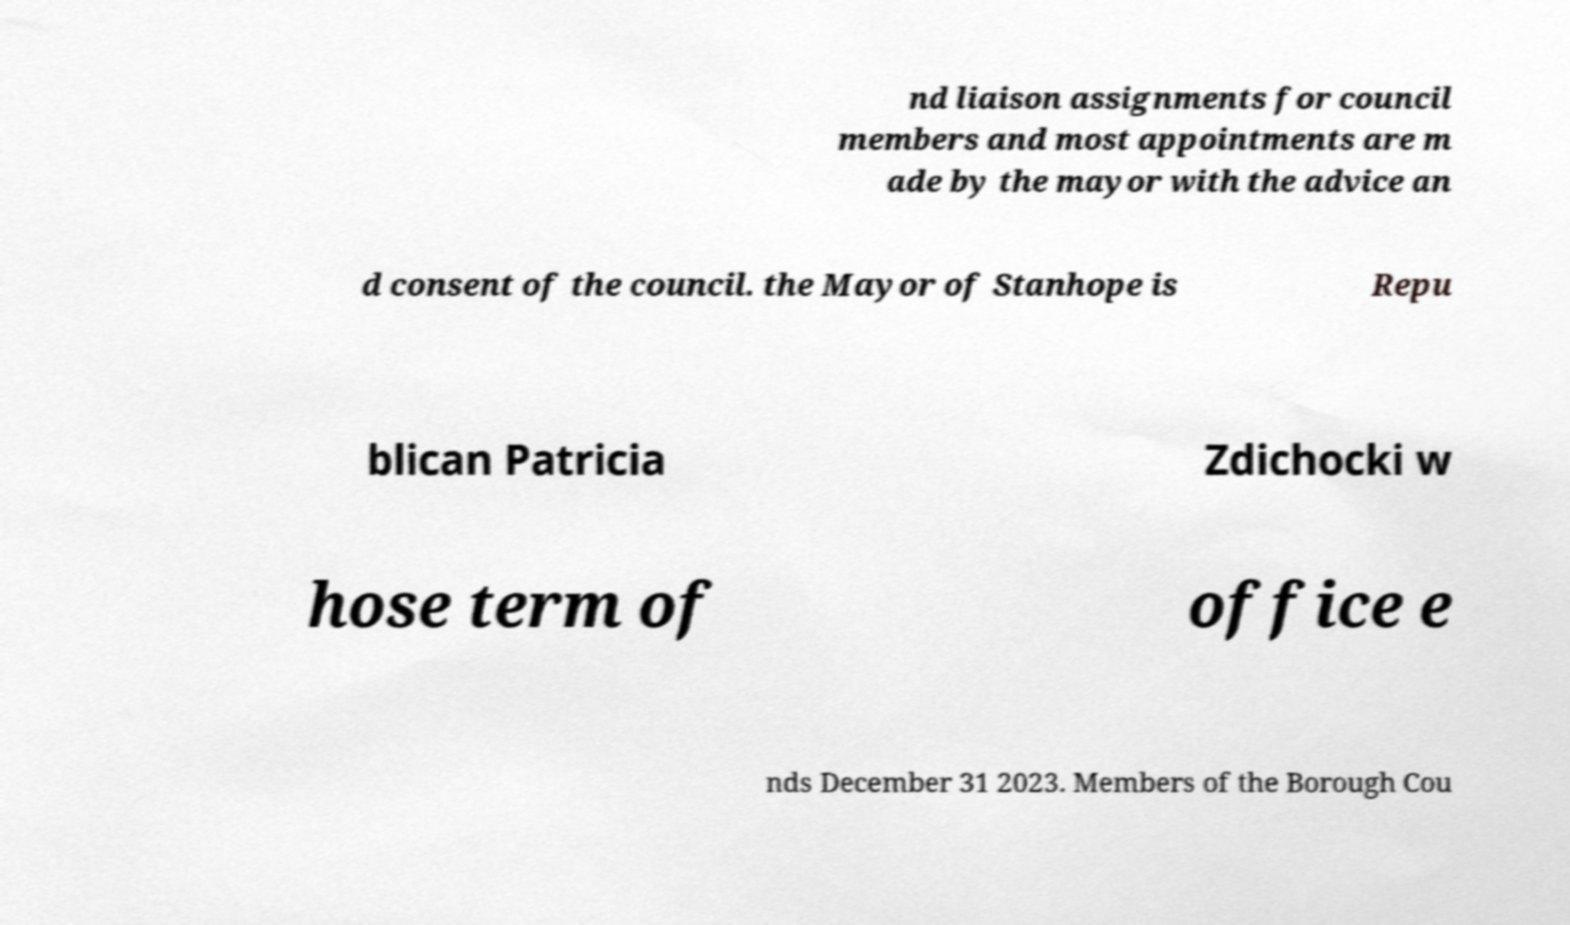Could you assist in decoding the text presented in this image and type it out clearly? nd liaison assignments for council members and most appointments are m ade by the mayor with the advice an d consent of the council. the Mayor of Stanhope is Repu blican Patricia Zdichocki w hose term of office e nds December 31 2023. Members of the Borough Cou 